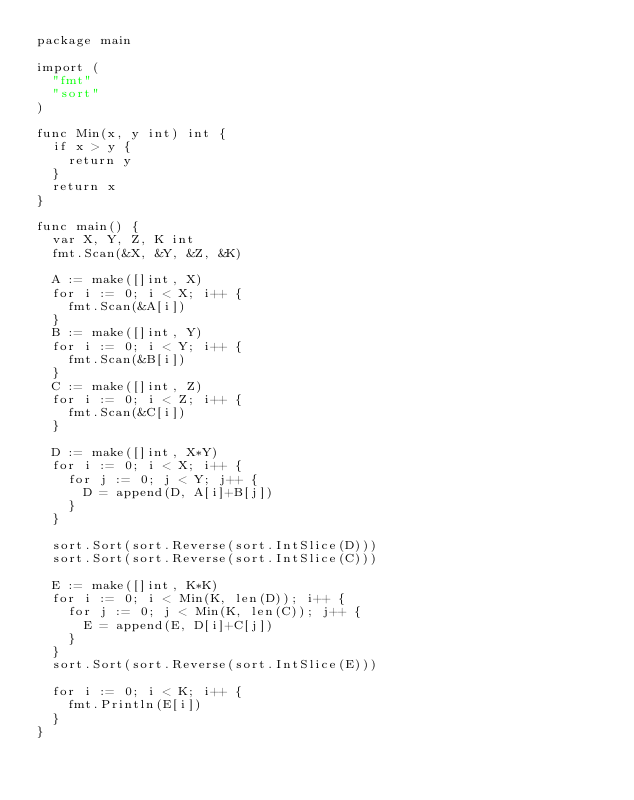<code> <loc_0><loc_0><loc_500><loc_500><_Go_>package main

import (
	"fmt"
	"sort"
)

func Min(x, y int) int {
	if x > y {
		return y
	}
	return x
}

func main() {
	var X, Y, Z, K int
	fmt.Scan(&X, &Y, &Z, &K)

	A := make([]int, X)
	for i := 0; i < X; i++ {
		fmt.Scan(&A[i])
	}
	B := make([]int, Y)
	for i := 0; i < Y; i++ {
		fmt.Scan(&B[i])
	}
	C := make([]int, Z)
	for i := 0; i < Z; i++ {
		fmt.Scan(&C[i])
	}

	D := make([]int, X*Y)
	for i := 0; i < X; i++ {
		for j := 0; j < Y; j++ {
			D = append(D, A[i]+B[j])
		}
	}

	sort.Sort(sort.Reverse(sort.IntSlice(D)))
	sort.Sort(sort.Reverse(sort.IntSlice(C)))

	E := make([]int, K*K)
	for i := 0; i < Min(K, len(D)); i++ {
		for j := 0; j < Min(K, len(C)); j++ {
			E = append(E, D[i]+C[j])
		}
	}
	sort.Sort(sort.Reverse(sort.IntSlice(E)))

	for i := 0; i < K; i++ {
		fmt.Println(E[i])
	}
}
</code> 